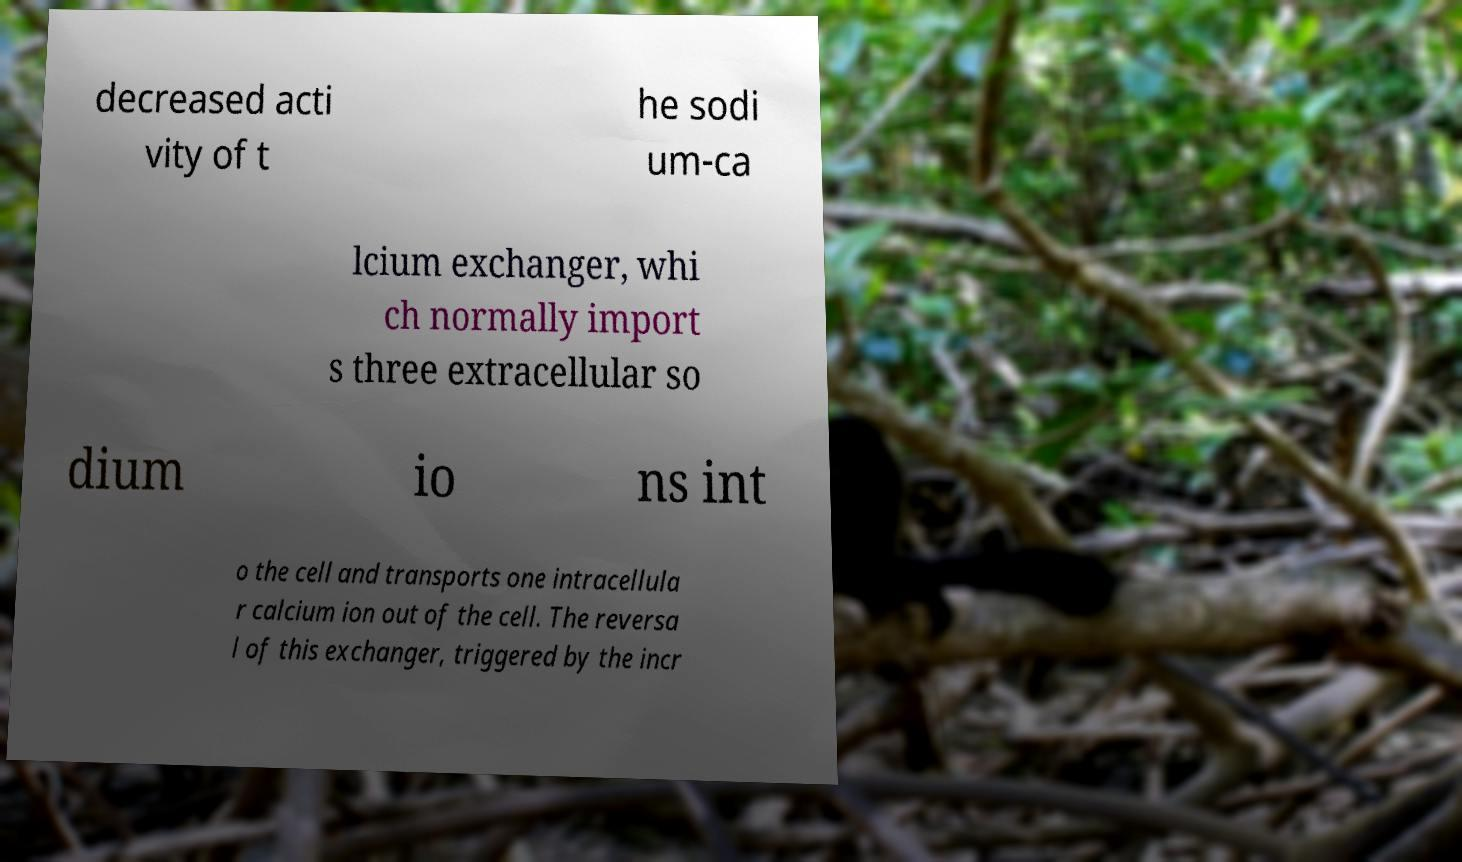For documentation purposes, I need the text within this image transcribed. Could you provide that? decreased acti vity of t he sodi um-ca lcium exchanger, whi ch normally import s three extracellular so dium io ns int o the cell and transports one intracellula r calcium ion out of the cell. The reversa l of this exchanger, triggered by the incr 